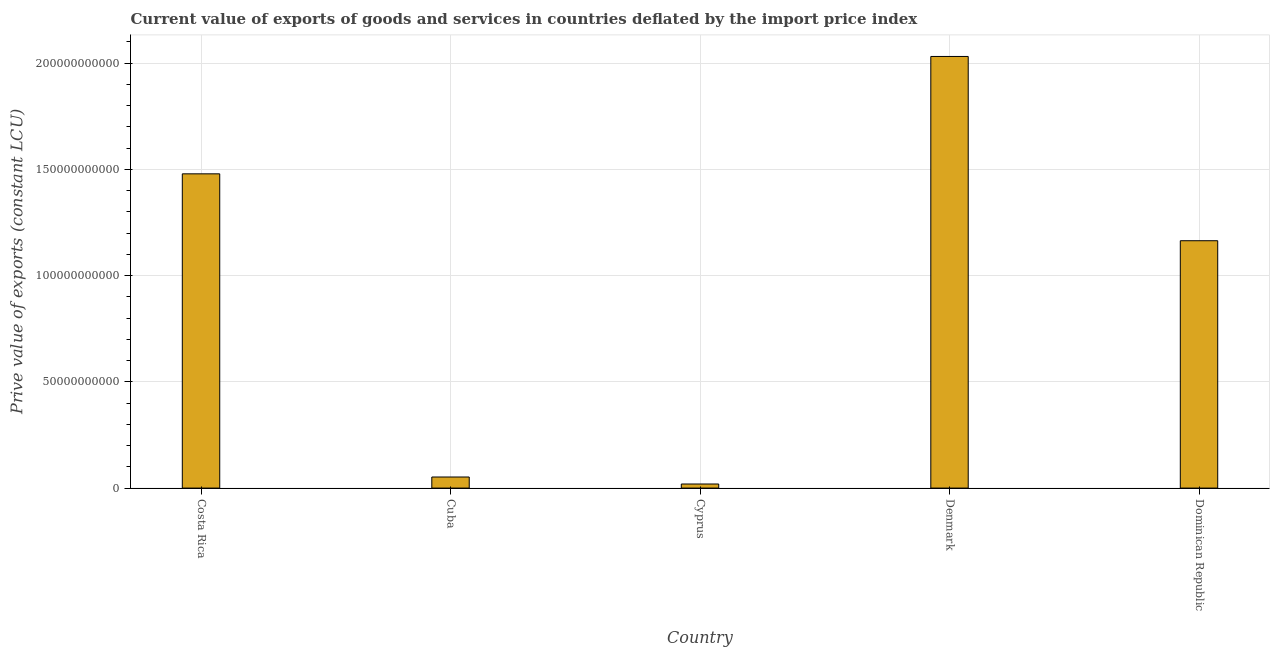What is the title of the graph?
Provide a succinct answer. Current value of exports of goods and services in countries deflated by the import price index. What is the label or title of the Y-axis?
Your response must be concise. Prive value of exports (constant LCU). What is the price value of exports in Dominican Republic?
Your answer should be compact. 1.16e+11. Across all countries, what is the maximum price value of exports?
Keep it short and to the point. 2.03e+11. Across all countries, what is the minimum price value of exports?
Your answer should be compact. 1.92e+09. In which country was the price value of exports minimum?
Keep it short and to the point. Cyprus. What is the sum of the price value of exports?
Keep it short and to the point. 4.75e+11. What is the difference between the price value of exports in Cyprus and Dominican Republic?
Keep it short and to the point. -1.15e+11. What is the average price value of exports per country?
Your response must be concise. 9.49e+1. What is the median price value of exports?
Give a very brief answer. 1.16e+11. What is the ratio of the price value of exports in Cuba to that in Dominican Republic?
Make the answer very short. 0.04. What is the difference between the highest and the second highest price value of exports?
Offer a terse response. 5.53e+1. What is the difference between the highest and the lowest price value of exports?
Give a very brief answer. 2.01e+11. In how many countries, is the price value of exports greater than the average price value of exports taken over all countries?
Provide a succinct answer. 3. How many bars are there?
Your response must be concise. 5. How many countries are there in the graph?
Your response must be concise. 5. What is the Prive value of exports (constant LCU) of Costa Rica?
Give a very brief answer. 1.48e+11. What is the Prive value of exports (constant LCU) of Cuba?
Give a very brief answer. 5.21e+09. What is the Prive value of exports (constant LCU) in Cyprus?
Your answer should be very brief. 1.92e+09. What is the Prive value of exports (constant LCU) of Denmark?
Offer a terse response. 2.03e+11. What is the Prive value of exports (constant LCU) of Dominican Republic?
Give a very brief answer. 1.16e+11. What is the difference between the Prive value of exports (constant LCU) in Costa Rica and Cuba?
Make the answer very short. 1.43e+11. What is the difference between the Prive value of exports (constant LCU) in Costa Rica and Cyprus?
Make the answer very short. 1.46e+11. What is the difference between the Prive value of exports (constant LCU) in Costa Rica and Denmark?
Your answer should be very brief. -5.53e+1. What is the difference between the Prive value of exports (constant LCU) in Costa Rica and Dominican Republic?
Provide a short and direct response. 3.15e+1. What is the difference between the Prive value of exports (constant LCU) in Cuba and Cyprus?
Keep it short and to the point. 3.29e+09. What is the difference between the Prive value of exports (constant LCU) in Cuba and Denmark?
Ensure brevity in your answer.  -1.98e+11. What is the difference between the Prive value of exports (constant LCU) in Cuba and Dominican Republic?
Keep it short and to the point. -1.11e+11. What is the difference between the Prive value of exports (constant LCU) in Cyprus and Denmark?
Your answer should be very brief. -2.01e+11. What is the difference between the Prive value of exports (constant LCU) in Cyprus and Dominican Republic?
Offer a terse response. -1.15e+11. What is the difference between the Prive value of exports (constant LCU) in Denmark and Dominican Republic?
Offer a very short reply. 8.67e+1. What is the ratio of the Prive value of exports (constant LCU) in Costa Rica to that in Cuba?
Your response must be concise. 28.37. What is the ratio of the Prive value of exports (constant LCU) in Costa Rica to that in Cyprus?
Ensure brevity in your answer.  77.02. What is the ratio of the Prive value of exports (constant LCU) in Costa Rica to that in Denmark?
Offer a very short reply. 0.73. What is the ratio of the Prive value of exports (constant LCU) in Costa Rica to that in Dominican Republic?
Ensure brevity in your answer.  1.27. What is the ratio of the Prive value of exports (constant LCU) in Cuba to that in Cyprus?
Offer a very short reply. 2.71. What is the ratio of the Prive value of exports (constant LCU) in Cuba to that in Denmark?
Provide a succinct answer. 0.03. What is the ratio of the Prive value of exports (constant LCU) in Cuba to that in Dominican Republic?
Your response must be concise. 0.04. What is the ratio of the Prive value of exports (constant LCU) in Cyprus to that in Denmark?
Your response must be concise. 0.01. What is the ratio of the Prive value of exports (constant LCU) in Cyprus to that in Dominican Republic?
Provide a short and direct response. 0.02. What is the ratio of the Prive value of exports (constant LCU) in Denmark to that in Dominican Republic?
Offer a terse response. 1.75. 